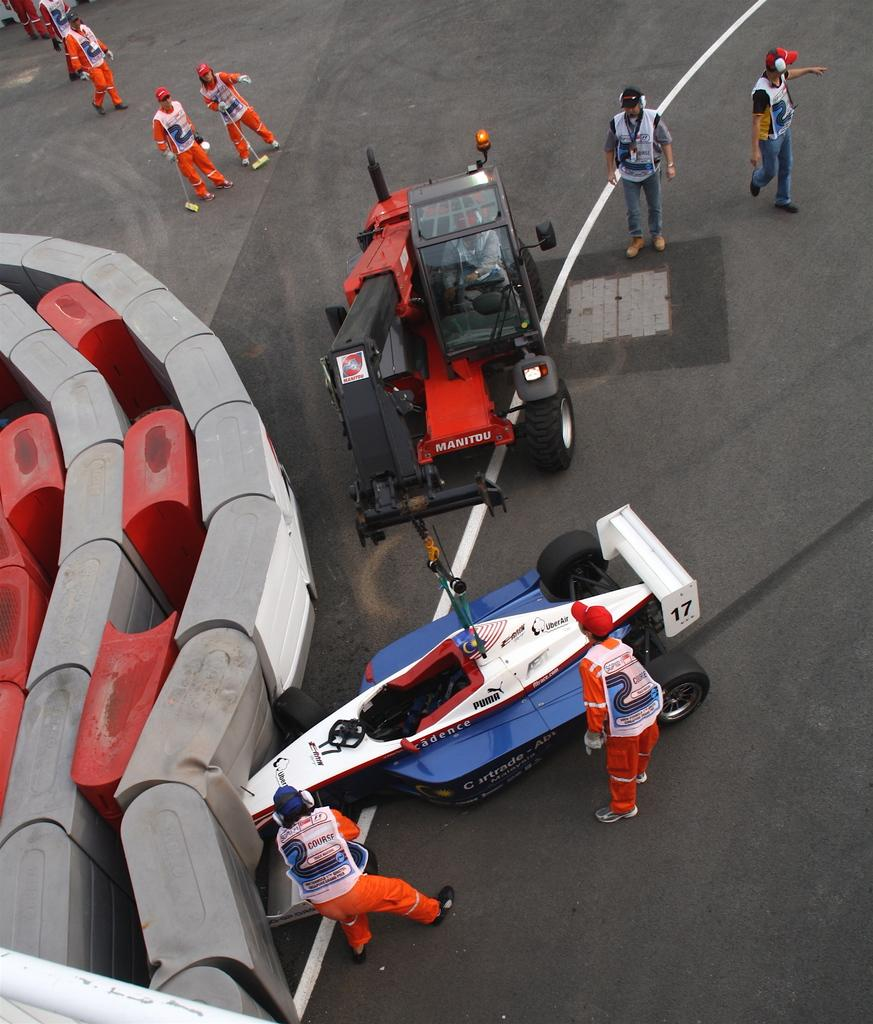What can be seen on the road in the image? There are vehicles and people standing on the road in the image. Can you describe the object on the left side of the image? Unfortunately, the provided facts do not mention any specific details about the object on the left side of the image. What might be the purpose of the people standing on the road? It is unclear from the image what the people are doing, but they could be waiting for a bus, crossing the street, or participating in an event. What type of square is being discussed by the committee in the image? There is no mention of a square, committee, or any discussion in the image. The image only shows vehicles and people on the road, along with an unspecified object on the left side. 